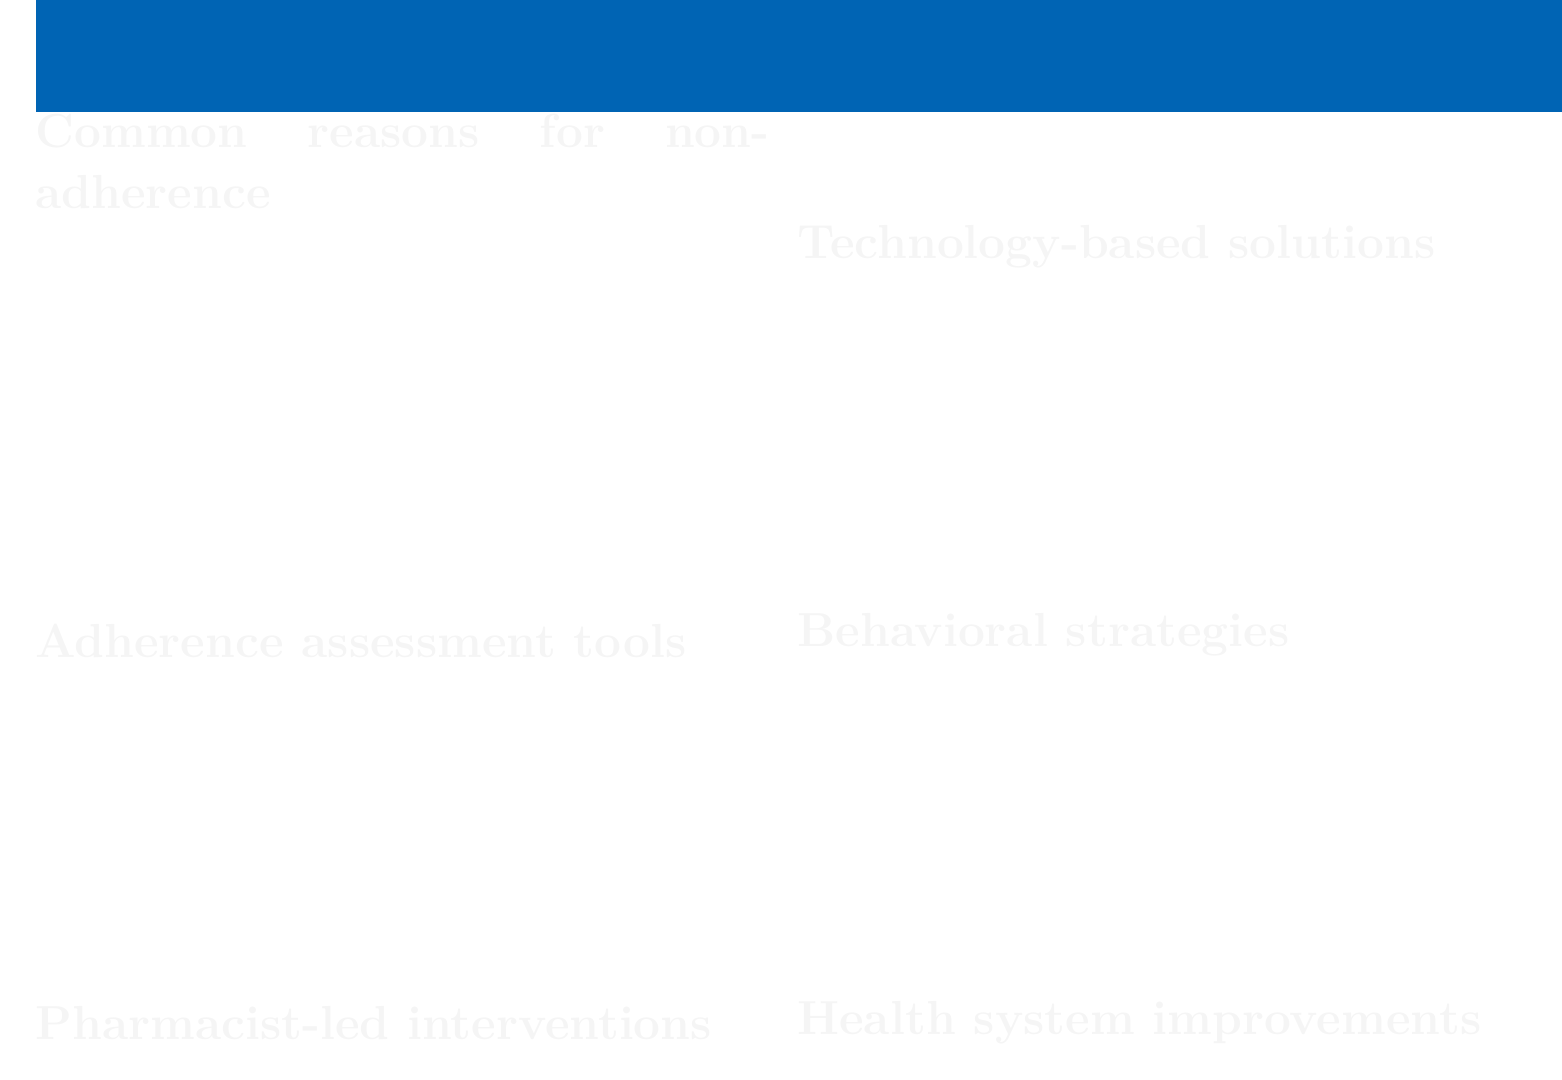What are common reasons for non-adherence? The document lists forgetfulness, complex medication schedules, side effects, cost of medications, and lack of understanding about the importance of treatment as common reasons for non-adherence.
Answer: forgetfulness, complex medication schedules, side effects, cost of medications, lack of understanding What is one adherence assessment tool mentioned? The document provides several adherence assessment tools, including the Morisky Medication Adherence Scale (MMAS-8).
Answer: Morisky Medication Adherence Scale (MMAS-8) What type of interventions can pharmacists lead? The document outlines several pharmacist-led interventions such as medication therapy management (MTM) services.
Answer: medication therapy management (MTM) services Name a technology-based solution for medication adherence. The document mentions solutions like smartphone medication reminder apps.
Answer: smartphone medication reminder apps What behavioral strategy involves setting objectives? The document lists goal-setting and action planning as a behavioral strategy that involves setting objectives.
Answer: goal-setting and action planning What is one health system improvement for adherence monitoring? The document suggests integration of adherence monitoring in electronic health records as a health system improvement.
Answer: integration of adherence monitoring in electronic health records How many common reasons for non-adherence are mentioned? The document lists five common reasons for non-adherence under the specified category.
Answer: five What can be involved in addressing barriers to adherence? The document states that identifying and addressing barriers to adherence can also involve family members or caregivers.
Answer: family members or caregivers Which motivational technique is mentioned? The document includes motivational interviewing techniques as a behavioral strategy.
Answer: motivational interviewing techniques 